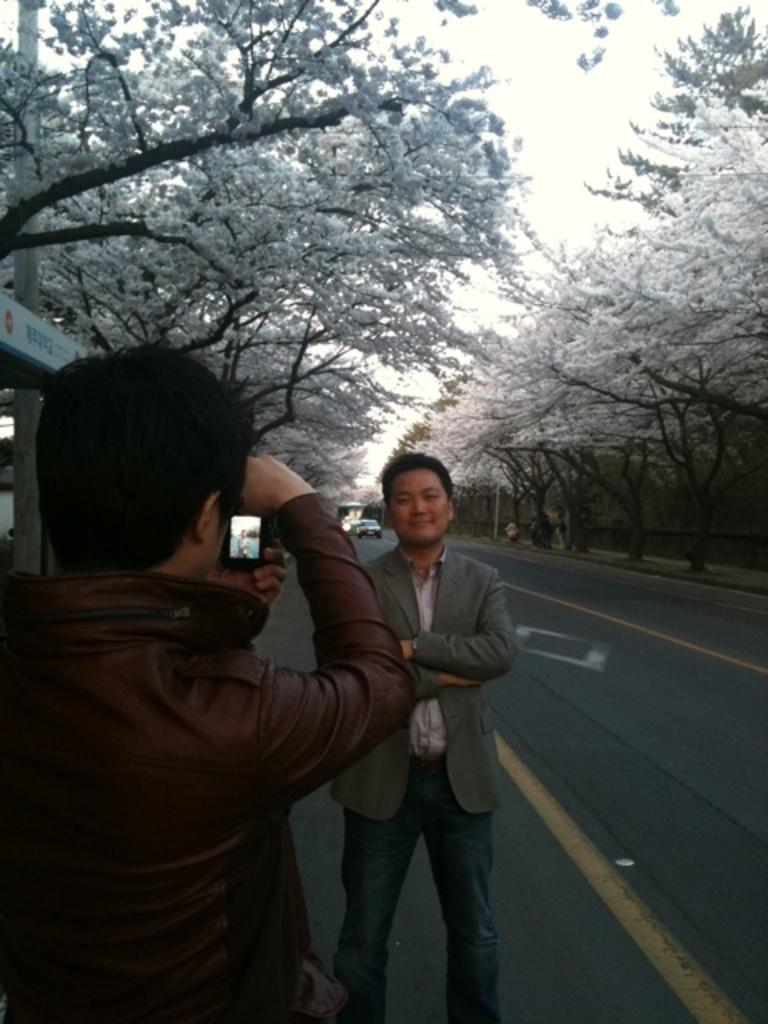What is the man doing in the image? The man is standing on the road in the image. What is the boy doing in the image? The boy is taking a photo in the image. What is the boy using to take the photo? The boy is using a camera to take the photo. What can be seen in the background of the image? There are trees with white flowers visible in the image. What type of sleep is the boy experiencing while taking the photo in the image? There is no indication of the boy sleeping or experiencing any type of sleep while taking the photo in the image. 